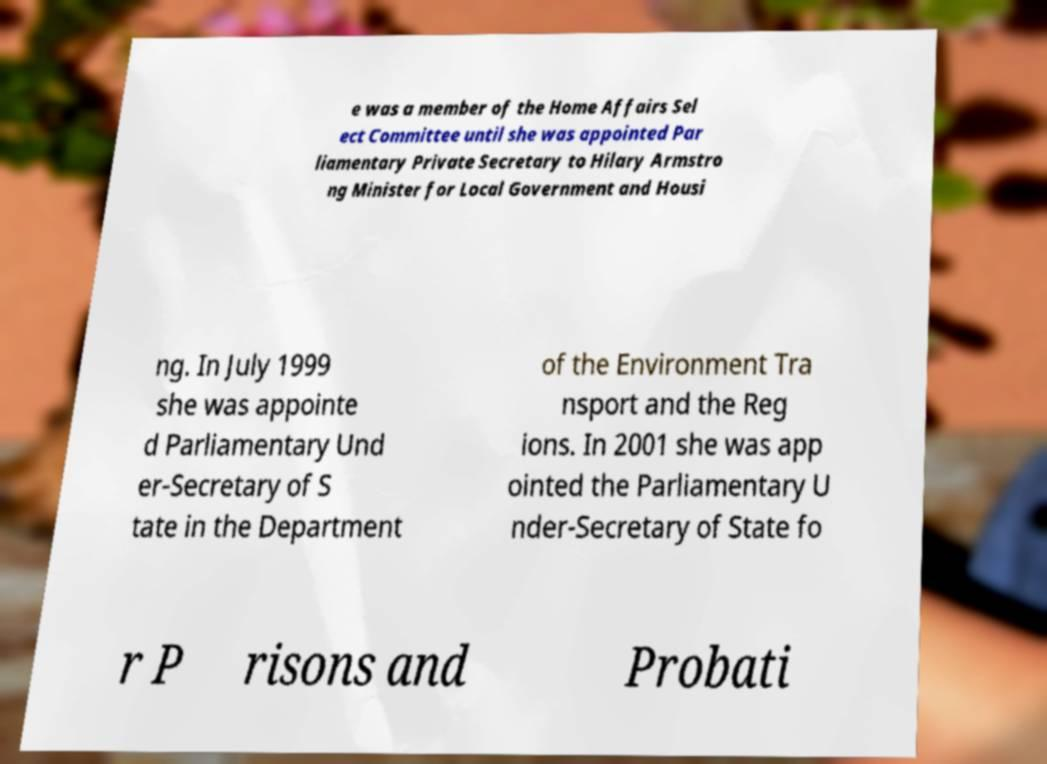Could you extract and type out the text from this image? e was a member of the Home Affairs Sel ect Committee until she was appointed Par liamentary Private Secretary to Hilary Armstro ng Minister for Local Government and Housi ng. In July 1999 she was appointe d Parliamentary Und er-Secretary of S tate in the Department of the Environment Tra nsport and the Reg ions. In 2001 she was app ointed the Parliamentary U nder-Secretary of State fo r P risons and Probati 